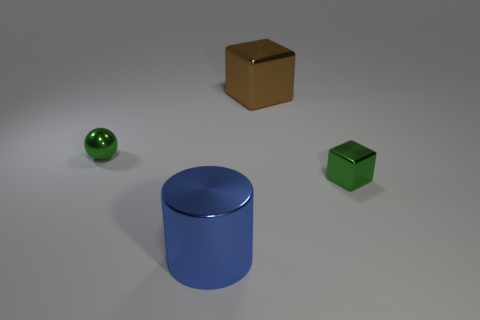Add 2 big brown things. How many objects exist? 6 Subtract 1 cubes. How many cubes are left? 1 Subtract 0 cyan balls. How many objects are left? 4 Subtract all spheres. How many objects are left? 3 Subtract all gray blocks. Subtract all cyan cylinders. How many blocks are left? 2 Subtract all gray spheres. How many green cubes are left? 1 Subtract all small purple shiny balls. Subtract all metal blocks. How many objects are left? 2 Add 1 cylinders. How many cylinders are left? 2 Add 2 small purple metal cylinders. How many small purple metal cylinders exist? 2 